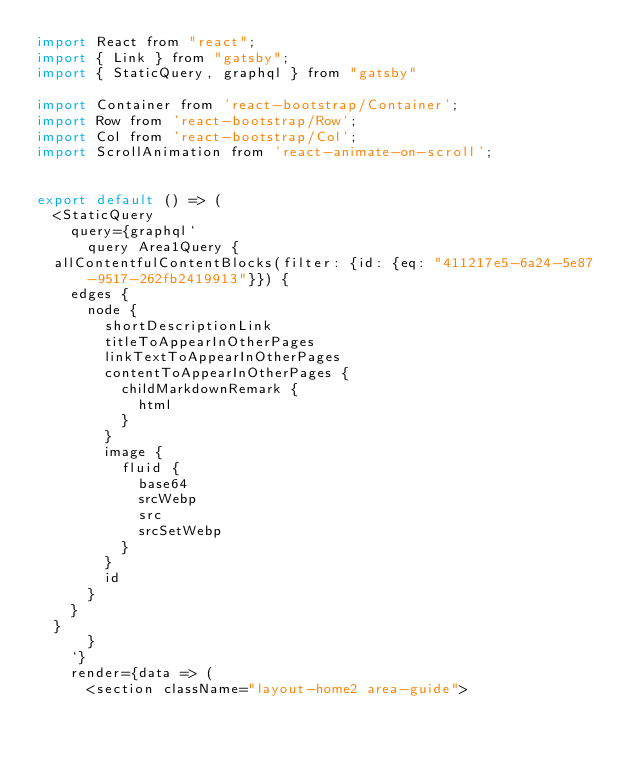<code> <loc_0><loc_0><loc_500><loc_500><_JavaScript_>import React from "react";
import { Link } from "gatsby";
import { StaticQuery, graphql } from "gatsby"

import Container from 'react-bootstrap/Container';
import Row from 'react-bootstrap/Row';
import Col from 'react-bootstrap/Col';
import ScrollAnimation from 'react-animate-on-scroll';


export default () => (
  <StaticQuery
    query={graphql`
      query Area1Query {
  allContentfulContentBlocks(filter: {id: {eq: "411217e5-6a24-5e87-9517-262fb2419913"}}) {
    edges {
      node {
        shortDescriptionLink
        titleToAppearInOtherPages
        linkTextToAppearInOtherPages
        contentToAppearInOtherPages {
          childMarkdownRemark {
            html
          }
        }
        image {
          fluid {
            base64
            srcWebp
            src
            srcSetWebp
          }
        }
        id
      }
    }
  }
      }
    `}
    render={data => (
      <section className="layout-home2 area-guide">

</code> 